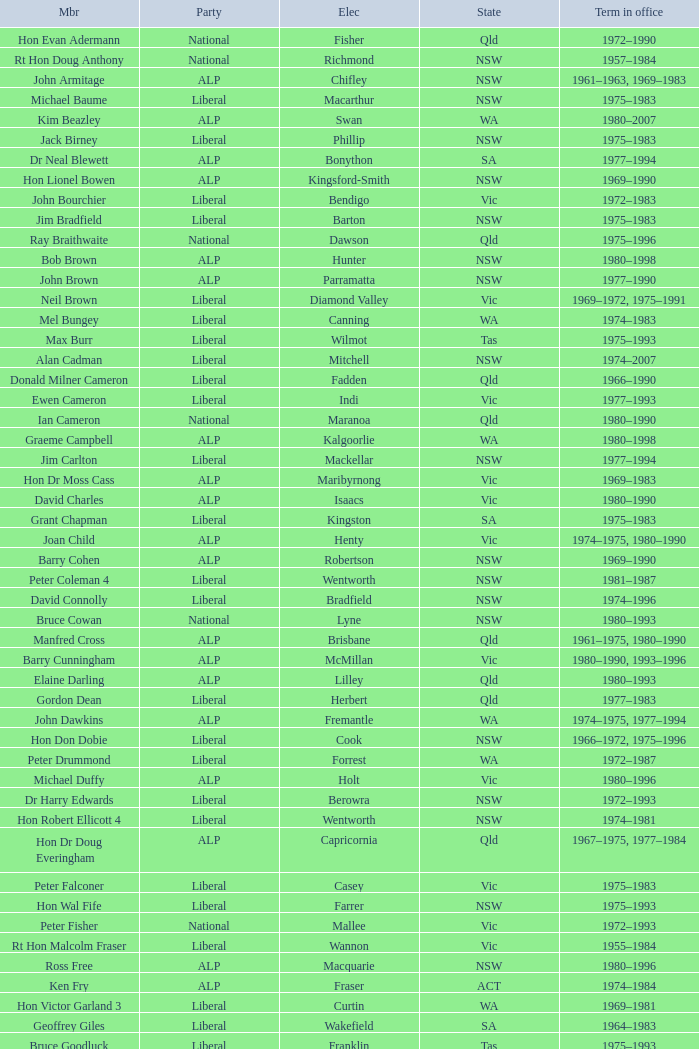Which party had a member from the state of Vic and an Electorate called Wannon? Liberal. 